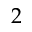<formula> <loc_0><loc_0><loc_500><loc_500>2</formula> 